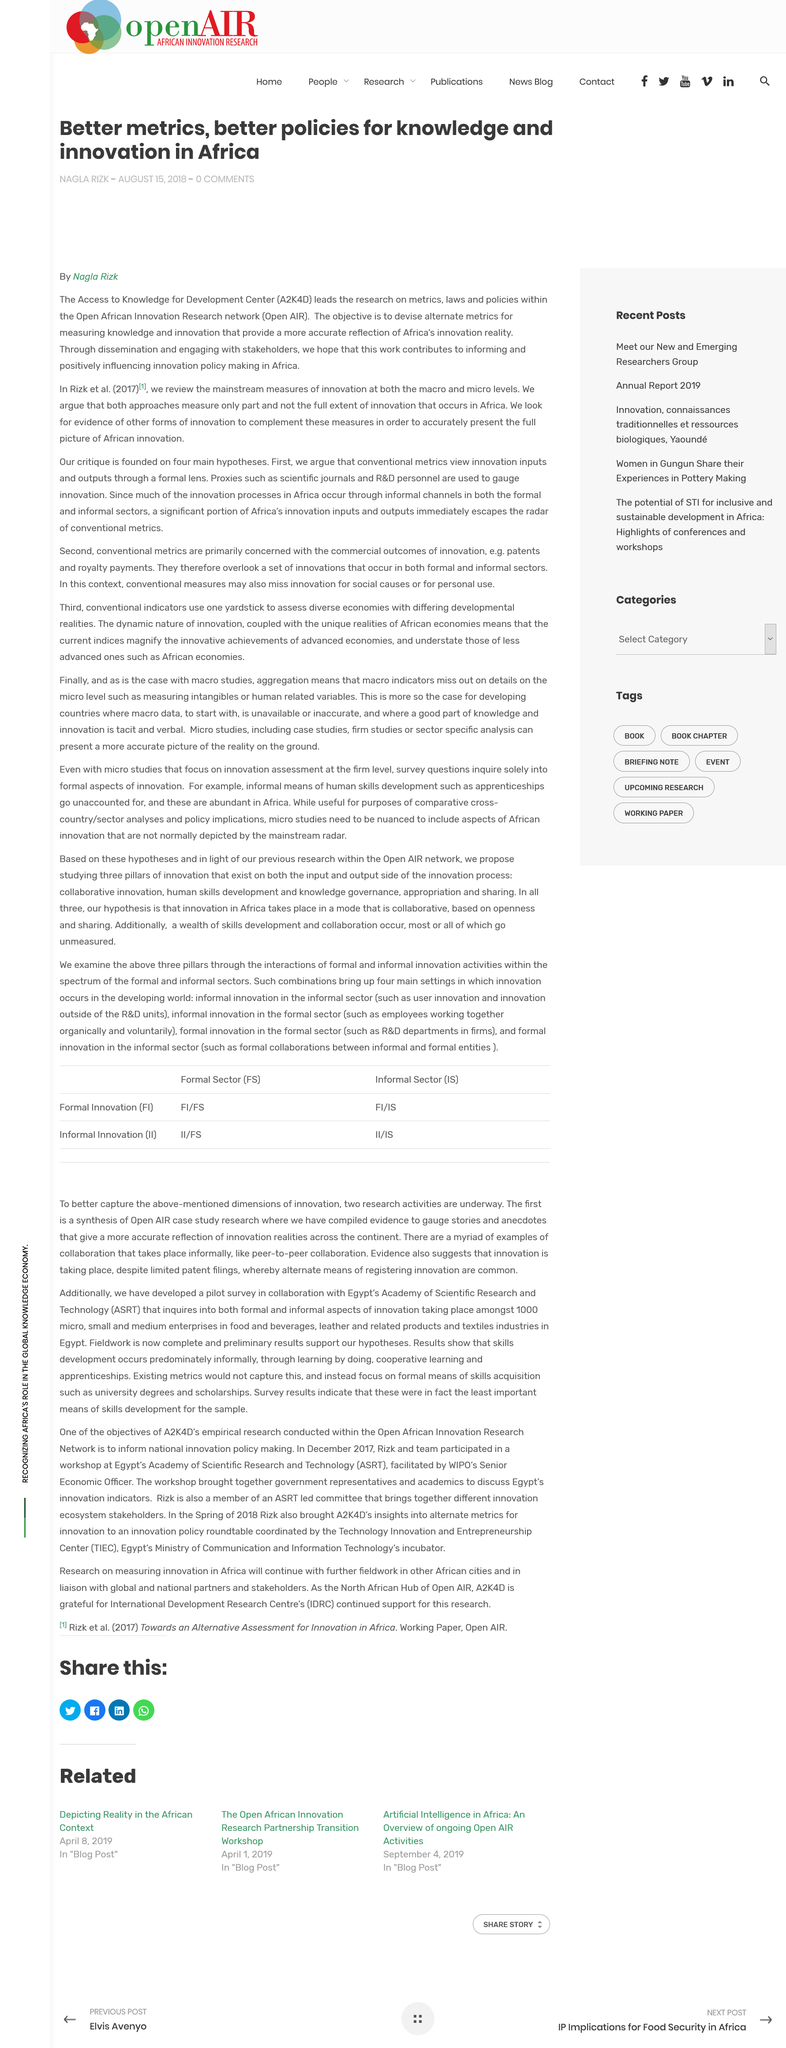Identify some key points in this picture. The acronym "A2K4D" stands for "Access to Knowledge for Development Center. The acronym 'AIR' in Open AIR stands for 'African Innovation Research'. The author of the review on innovation measures at both macro and micro levels is named Nagla. 